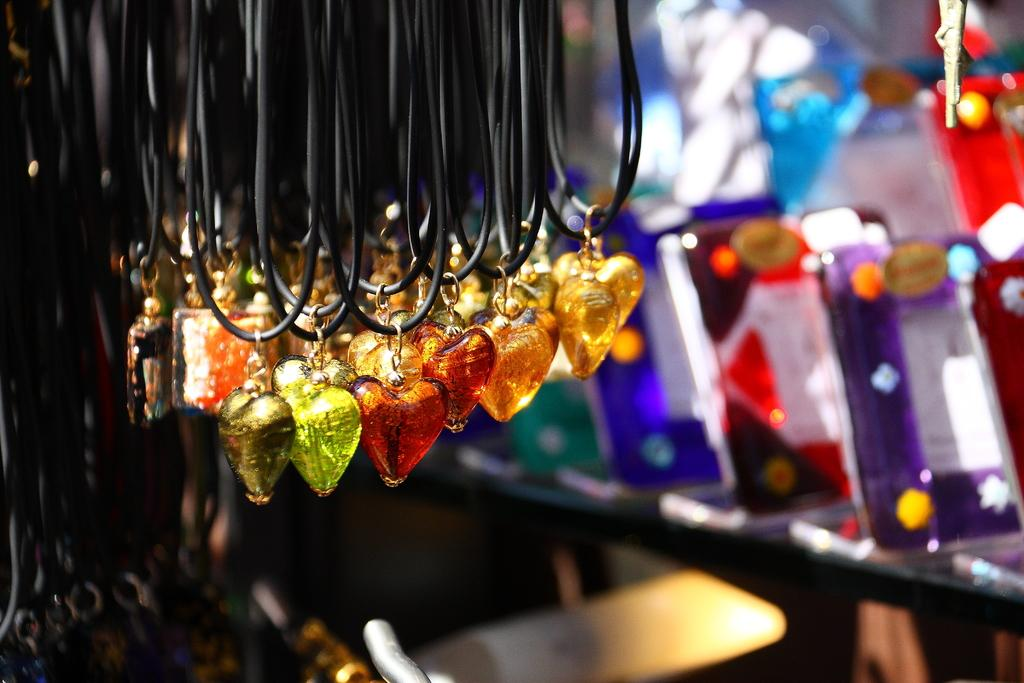What type of jewelry is present in the image? There are lockets in the image. Where are the lockets located in the image? The lockets are in the middle of the image. What colors are the lockets in the image? The lockets are in green, red, and orange colors. What type of straw is used to make the wheel in the image? There is no straw or wheel present in the image; it features lockets in green, red, and orange colors. 